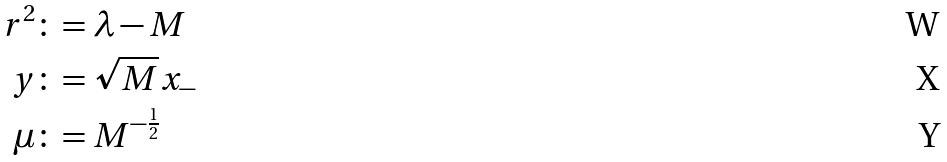<formula> <loc_0><loc_0><loc_500><loc_500>r ^ { 2 } & \colon = \lambda - M \\ y & \colon = \sqrt { M } x _ { - } \\ \mu & \colon = M ^ { - \frac { 1 } { 2 } }</formula> 